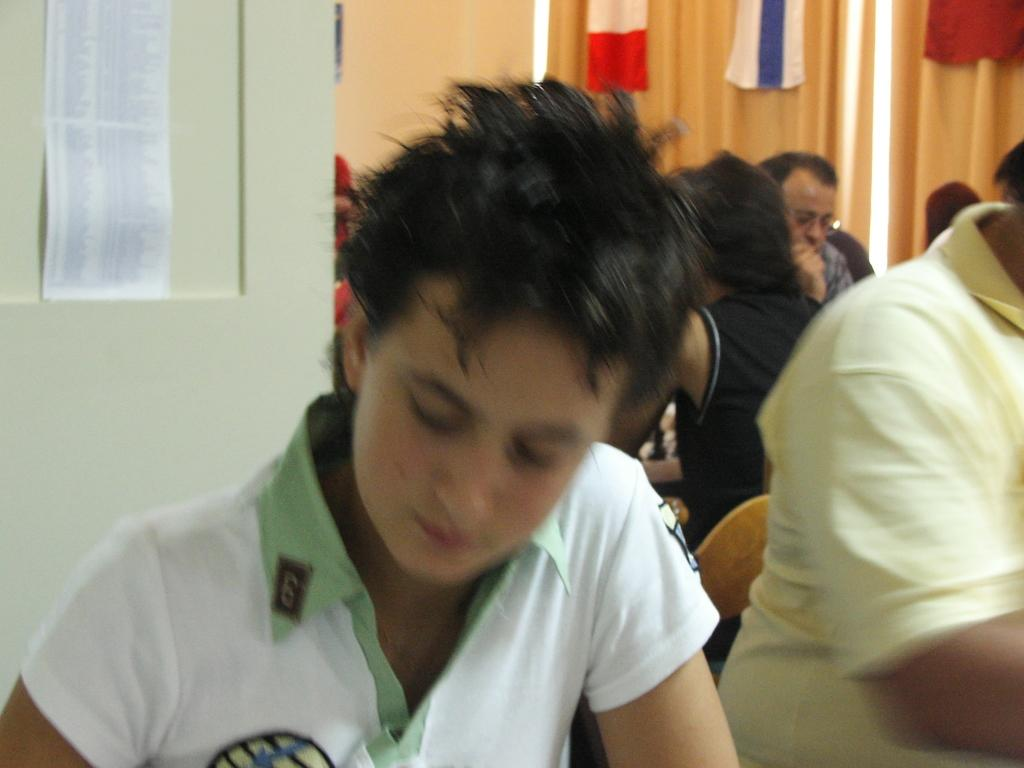Where was the image taken? The image was taken indoors. What is happening in the image? There is a group of people in the image, and they are sitting on chairs. What can be seen in the background of the image? There is a wall, curtains, and other unspecified objects in the background of the image. What type of grape is being used as a decoration on the chairs in the image? There is no grape present in the image, and the chairs do not have any decorations. How many potatoes are visible on the wall in the background of the image? There are no potatoes visible on the wall or anywhere else in the image. 